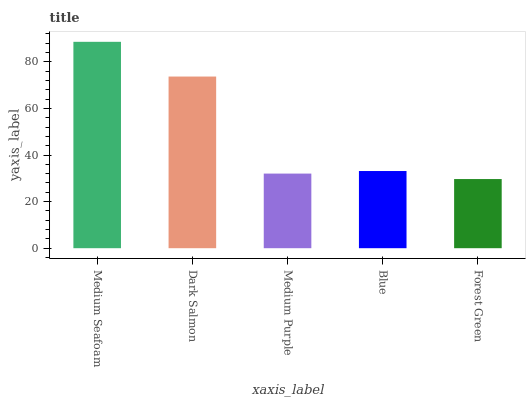Is Forest Green the minimum?
Answer yes or no. Yes. Is Medium Seafoam the maximum?
Answer yes or no. Yes. Is Dark Salmon the minimum?
Answer yes or no. No. Is Dark Salmon the maximum?
Answer yes or no. No. Is Medium Seafoam greater than Dark Salmon?
Answer yes or no. Yes. Is Dark Salmon less than Medium Seafoam?
Answer yes or no. Yes. Is Dark Salmon greater than Medium Seafoam?
Answer yes or no. No. Is Medium Seafoam less than Dark Salmon?
Answer yes or no. No. Is Blue the high median?
Answer yes or no. Yes. Is Blue the low median?
Answer yes or no. Yes. Is Medium Seafoam the high median?
Answer yes or no. No. Is Medium Purple the low median?
Answer yes or no. No. 